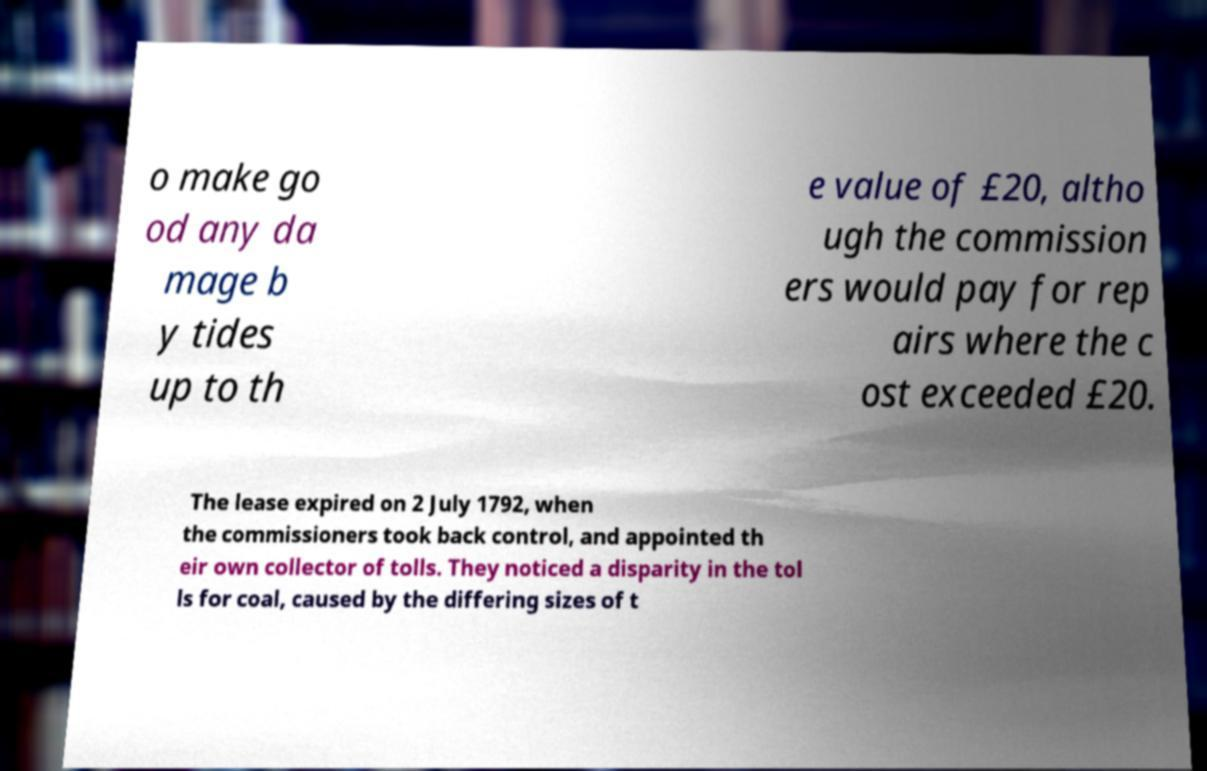Can you accurately transcribe the text from the provided image for me? o make go od any da mage b y tides up to th e value of £20, altho ugh the commission ers would pay for rep airs where the c ost exceeded £20. The lease expired on 2 July 1792, when the commissioners took back control, and appointed th eir own collector of tolls. They noticed a disparity in the tol ls for coal, caused by the differing sizes of t 